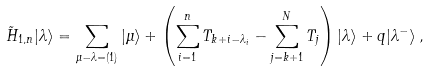Convert formula to latex. <formula><loc_0><loc_0><loc_500><loc_500>\tilde { H } _ { 1 , n } | \lambda \rangle = \sum _ { \mu - \lambda = ( 1 ) } | \mu \rangle + \left ( \sum _ { i = 1 } ^ { n } T _ { k + i - \lambda _ { i } } - \sum _ { j = k + 1 } ^ { N } T _ { j } \right ) | \lambda \rangle + q | \lambda ^ { - } \rangle \, ,</formula> 